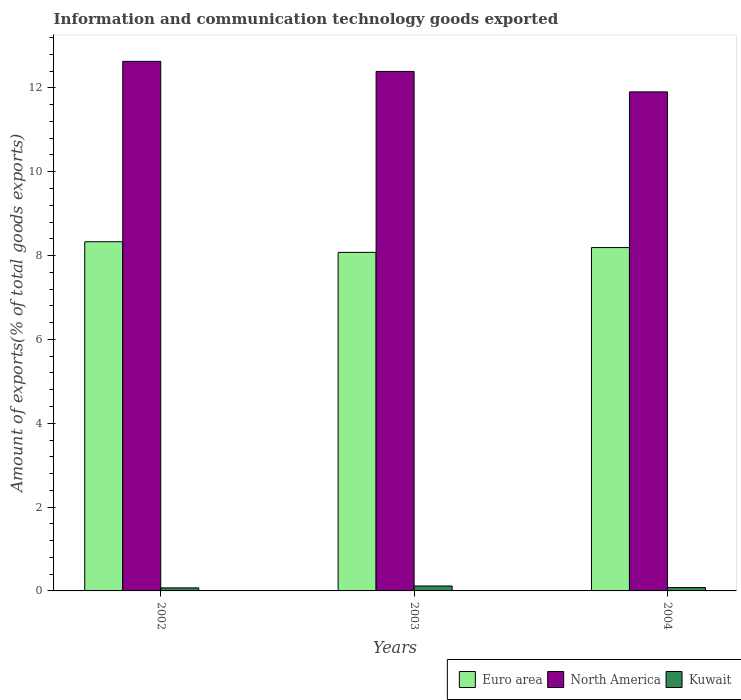How many different coloured bars are there?
Make the answer very short. 3. Are the number of bars on each tick of the X-axis equal?
Your response must be concise. Yes. How many bars are there on the 2nd tick from the right?
Your answer should be compact. 3. In how many cases, is the number of bars for a given year not equal to the number of legend labels?
Provide a succinct answer. 0. What is the amount of goods exported in Kuwait in 2003?
Provide a succinct answer. 0.12. Across all years, what is the maximum amount of goods exported in Euro area?
Your answer should be compact. 8.33. Across all years, what is the minimum amount of goods exported in North America?
Your response must be concise. 11.9. What is the total amount of goods exported in North America in the graph?
Provide a short and direct response. 36.93. What is the difference between the amount of goods exported in Kuwait in 2002 and that in 2003?
Ensure brevity in your answer.  -0.05. What is the difference between the amount of goods exported in Euro area in 2003 and the amount of goods exported in Kuwait in 2002?
Offer a very short reply. 8. What is the average amount of goods exported in Euro area per year?
Your response must be concise. 8.2. In the year 2003, what is the difference between the amount of goods exported in North America and amount of goods exported in Euro area?
Offer a terse response. 4.32. In how many years, is the amount of goods exported in North America greater than 2.8 %?
Offer a very short reply. 3. What is the ratio of the amount of goods exported in North America in 2002 to that in 2004?
Offer a very short reply. 1.06. Is the amount of goods exported in Kuwait in 2002 less than that in 2004?
Your response must be concise. Yes. What is the difference between the highest and the second highest amount of goods exported in Kuwait?
Your response must be concise. 0.04. What is the difference between the highest and the lowest amount of goods exported in North America?
Offer a very short reply. 0.73. Is the sum of the amount of goods exported in Kuwait in 2002 and 2003 greater than the maximum amount of goods exported in Euro area across all years?
Offer a very short reply. No. What does the 3rd bar from the left in 2004 represents?
Provide a short and direct response. Kuwait. What does the 1st bar from the right in 2002 represents?
Give a very brief answer. Kuwait. Is it the case that in every year, the sum of the amount of goods exported in North America and amount of goods exported in Kuwait is greater than the amount of goods exported in Euro area?
Make the answer very short. Yes. How many bars are there?
Offer a terse response. 9. How many years are there in the graph?
Keep it short and to the point. 3. What is the difference between two consecutive major ticks on the Y-axis?
Your response must be concise. 2. Are the values on the major ticks of Y-axis written in scientific E-notation?
Your answer should be very brief. No. Does the graph contain any zero values?
Provide a short and direct response. No. Does the graph contain grids?
Your answer should be compact. No. How are the legend labels stacked?
Keep it short and to the point. Horizontal. What is the title of the graph?
Offer a terse response. Information and communication technology goods exported. What is the label or title of the Y-axis?
Provide a succinct answer. Amount of exports(% of total goods exports). What is the Amount of exports(% of total goods exports) of Euro area in 2002?
Provide a succinct answer. 8.33. What is the Amount of exports(% of total goods exports) in North America in 2002?
Offer a very short reply. 12.63. What is the Amount of exports(% of total goods exports) in Kuwait in 2002?
Offer a very short reply. 0.07. What is the Amount of exports(% of total goods exports) of Euro area in 2003?
Offer a terse response. 8.08. What is the Amount of exports(% of total goods exports) in North America in 2003?
Provide a short and direct response. 12.39. What is the Amount of exports(% of total goods exports) of Kuwait in 2003?
Your answer should be very brief. 0.12. What is the Amount of exports(% of total goods exports) of Euro area in 2004?
Offer a terse response. 8.19. What is the Amount of exports(% of total goods exports) of North America in 2004?
Ensure brevity in your answer.  11.9. What is the Amount of exports(% of total goods exports) of Kuwait in 2004?
Your response must be concise. 0.08. Across all years, what is the maximum Amount of exports(% of total goods exports) of Euro area?
Provide a succinct answer. 8.33. Across all years, what is the maximum Amount of exports(% of total goods exports) of North America?
Make the answer very short. 12.63. Across all years, what is the maximum Amount of exports(% of total goods exports) of Kuwait?
Make the answer very short. 0.12. Across all years, what is the minimum Amount of exports(% of total goods exports) of Euro area?
Offer a terse response. 8.08. Across all years, what is the minimum Amount of exports(% of total goods exports) in North America?
Provide a short and direct response. 11.9. Across all years, what is the minimum Amount of exports(% of total goods exports) in Kuwait?
Your response must be concise. 0.07. What is the total Amount of exports(% of total goods exports) in Euro area in the graph?
Offer a terse response. 24.6. What is the total Amount of exports(% of total goods exports) in North America in the graph?
Ensure brevity in your answer.  36.93. What is the total Amount of exports(% of total goods exports) in Kuwait in the graph?
Offer a very short reply. 0.27. What is the difference between the Amount of exports(% of total goods exports) of Euro area in 2002 and that in 2003?
Your response must be concise. 0.25. What is the difference between the Amount of exports(% of total goods exports) of North America in 2002 and that in 2003?
Offer a terse response. 0.24. What is the difference between the Amount of exports(% of total goods exports) of Kuwait in 2002 and that in 2003?
Provide a succinct answer. -0.05. What is the difference between the Amount of exports(% of total goods exports) in Euro area in 2002 and that in 2004?
Make the answer very short. 0.14. What is the difference between the Amount of exports(% of total goods exports) in North America in 2002 and that in 2004?
Your response must be concise. 0.73. What is the difference between the Amount of exports(% of total goods exports) in Kuwait in 2002 and that in 2004?
Offer a terse response. -0.01. What is the difference between the Amount of exports(% of total goods exports) in Euro area in 2003 and that in 2004?
Your response must be concise. -0.11. What is the difference between the Amount of exports(% of total goods exports) in North America in 2003 and that in 2004?
Give a very brief answer. 0.49. What is the difference between the Amount of exports(% of total goods exports) in Kuwait in 2003 and that in 2004?
Provide a succinct answer. 0.04. What is the difference between the Amount of exports(% of total goods exports) of Euro area in 2002 and the Amount of exports(% of total goods exports) of North America in 2003?
Provide a succinct answer. -4.06. What is the difference between the Amount of exports(% of total goods exports) in Euro area in 2002 and the Amount of exports(% of total goods exports) in Kuwait in 2003?
Your answer should be very brief. 8.21. What is the difference between the Amount of exports(% of total goods exports) of North America in 2002 and the Amount of exports(% of total goods exports) of Kuwait in 2003?
Keep it short and to the point. 12.51. What is the difference between the Amount of exports(% of total goods exports) of Euro area in 2002 and the Amount of exports(% of total goods exports) of North America in 2004?
Your response must be concise. -3.57. What is the difference between the Amount of exports(% of total goods exports) in Euro area in 2002 and the Amount of exports(% of total goods exports) in Kuwait in 2004?
Make the answer very short. 8.25. What is the difference between the Amount of exports(% of total goods exports) of North America in 2002 and the Amount of exports(% of total goods exports) of Kuwait in 2004?
Ensure brevity in your answer.  12.55. What is the difference between the Amount of exports(% of total goods exports) of Euro area in 2003 and the Amount of exports(% of total goods exports) of North America in 2004?
Provide a succinct answer. -3.83. What is the difference between the Amount of exports(% of total goods exports) in Euro area in 2003 and the Amount of exports(% of total goods exports) in Kuwait in 2004?
Provide a succinct answer. 8. What is the difference between the Amount of exports(% of total goods exports) in North America in 2003 and the Amount of exports(% of total goods exports) in Kuwait in 2004?
Ensure brevity in your answer.  12.31. What is the average Amount of exports(% of total goods exports) in Euro area per year?
Offer a terse response. 8.2. What is the average Amount of exports(% of total goods exports) in North America per year?
Your answer should be very brief. 12.31. What is the average Amount of exports(% of total goods exports) in Kuwait per year?
Keep it short and to the point. 0.09. In the year 2002, what is the difference between the Amount of exports(% of total goods exports) in Euro area and Amount of exports(% of total goods exports) in North America?
Provide a succinct answer. -4.3. In the year 2002, what is the difference between the Amount of exports(% of total goods exports) in Euro area and Amount of exports(% of total goods exports) in Kuwait?
Keep it short and to the point. 8.26. In the year 2002, what is the difference between the Amount of exports(% of total goods exports) in North America and Amount of exports(% of total goods exports) in Kuwait?
Provide a short and direct response. 12.56. In the year 2003, what is the difference between the Amount of exports(% of total goods exports) in Euro area and Amount of exports(% of total goods exports) in North America?
Offer a very short reply. -4.32. In the year 2003, what is the difference between the Amount of exports(% of total goods exports) in Euro area and Amount of exports(% of total goods exports) in Kuwait?
Your answer should be very brief. 7.96. In the year 2003, what is the difference between the Amount of exports(% of total goods exports) in North America and Amount of exports(% of total goods exports) in Kuwait?
Provide a short and direct response. 12.27. In the year 2004, what is the difference between the Amount of exports(% of total goods exports) of Euro area and Amount of exports(% of total goods exports) of North America?
Ensure brevity in your answer.  -3.71. In the year 2004, what is the difference between the Amount of exports(% of total goods exports) of Euro area and Amount of exports(% of total goods exports) of Kuwait?
Your response must be concise. 8.11. In the year 2004, what is the difference between the Amount of exports(% of total goods exports) in North America and Amount of exports(% of total goods exports) in Kuwait?
Keep it short and to the point. 11.82. What is the ratio of the Amount of exports(% of total goods exports) in Euro area in 2002 to that in 2003?
Your answer should be very brief. 1.03. What is the ratio of the Amount of exports(% of total goods exports) in North America in 2002 to that in 2003?
Offer a terse response. 1.02. What is the ratio of the Amount of exports(% of total goods exports) in Kuwait in 2002 to that in 2003?
Your answer should be compact. 0.62. What is the ratio of the Amount of exports(% of total goods exports) of Euro area in 2002 to that in 2004?
Your response must be concise. 1.02. What is the ratio of the Amount of exports(% of total goods exports) in North America in 2002 to that in 2004?
Give a very brief answer. 1.06. What is the ratio of the Amount of exports(% of total goods exports) of Kuwait in 2002 to that in 2004?
Make the answer very short. 0.91. What is the ratio of the Amount of exports(% of total goods exports) of North America in 2003 to that in 2004?
Keep it short and to the point. 1.04. What is the ratio of the Amount of exports(% of total goods exports) of Kuwait in 2003 to that in 2004?
Your answer should be compact. 1.48. What is the difference between the highest and the second highest Amount of exports(% of total goods exports) of Euro area?
Your response must be concise. 0.14. What is the difference between the highest and the second highest Amount of exports(% of total goods exports) of North America?
Give a very brief answer. 0.24. What is the difference between the highest and the second highest Amount of exports(% of total goods exports) in Kuwait?
Your answer should be compact. 0.04. What is the difference between the highest and the lowest Amount of exports(% of total goods exports) of Euro area?
Provide a short and direct response. 0.25. What is the difference between the highest and the lowest Amount of exports(% of total goods exports) of North America?
Your response must be concise. 0.73. What is the difference between the highest and the lowest Amount of exports(% of total goods exports) of Kuwait?
Provide a short and direct response. 0.05. 